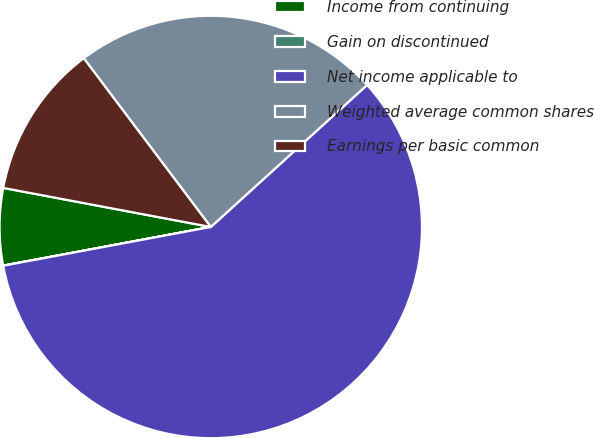Convert chart to OTSL. <chart><loc_0><loc_0><loc_500><loc_500><pie_chart><fcel>Income from continuing<fcel>Gain on discontinued<fcel>Net income applicable to<fcel>Weighted average common shares<fcel>Earnings per basic common<nl><fcel>5.89%<fcel>0.01%<fcel>58.8%<fcel>23.53%<fcel>11.77%<nl></chart> 